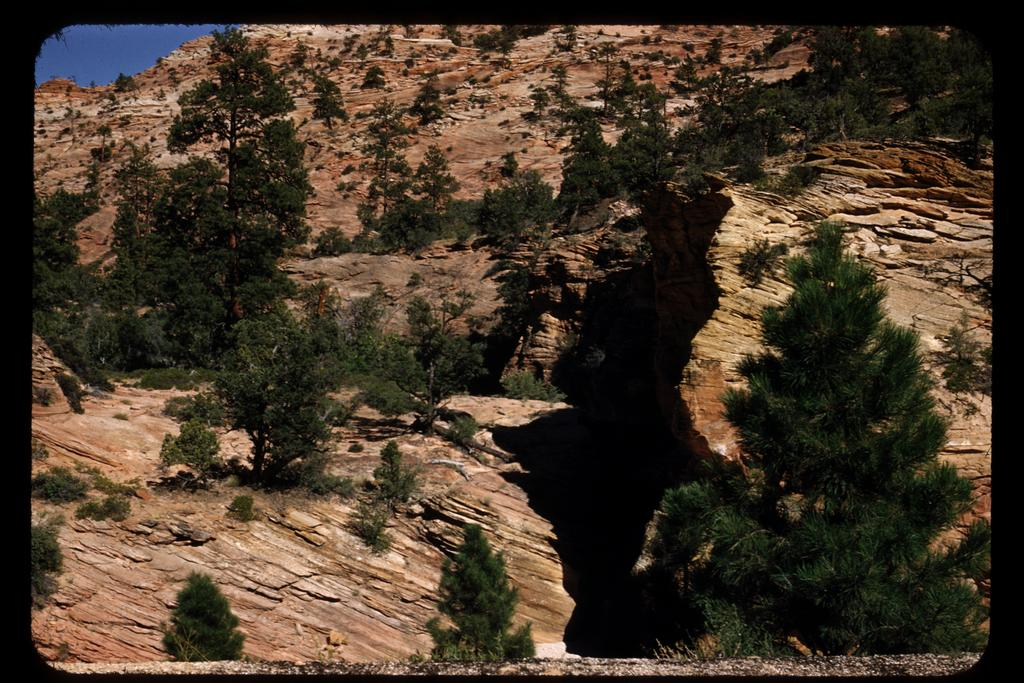What type of natural elements can be seen in the image? There are trees and plants in the image. Are there any other objects or features in the image besides the natural elements? Yes, there are rocks in the image. What holiday is being celebrated in the image? There is no indication of a holiday being celebrated in the image. Which company is responsible for the plants and trees in the image? The image does not provide information about a specific company being responsible for the plants and trees. 